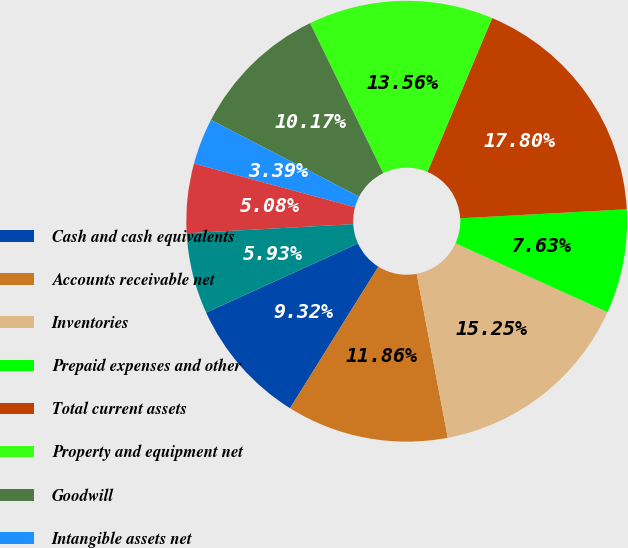Convert chart to OTSL. <chart><loc_0><loc_0><loc_500><loc_500><pie_chart><fcel>Cash and cash equivalents<fcel>Accounts receivable net<fcel>Inventories<fcel>Prepaid expenses and other<fcel>Total current assets<fcel>Property and equipment net<fcel>Goodwill<fcel>Intangible assets net<fcel>Deferred income taxes<fcel>Other long term assets<nl><fcel>9.32%<fcel>11.86%<fcel>15.25%<fcel>7.63%<fcel>17.8%<fcel>13.56%<fcel>10.17%<fcel>3.39%<fcel>5.08%<fcel>5.93%<nl></chart> 